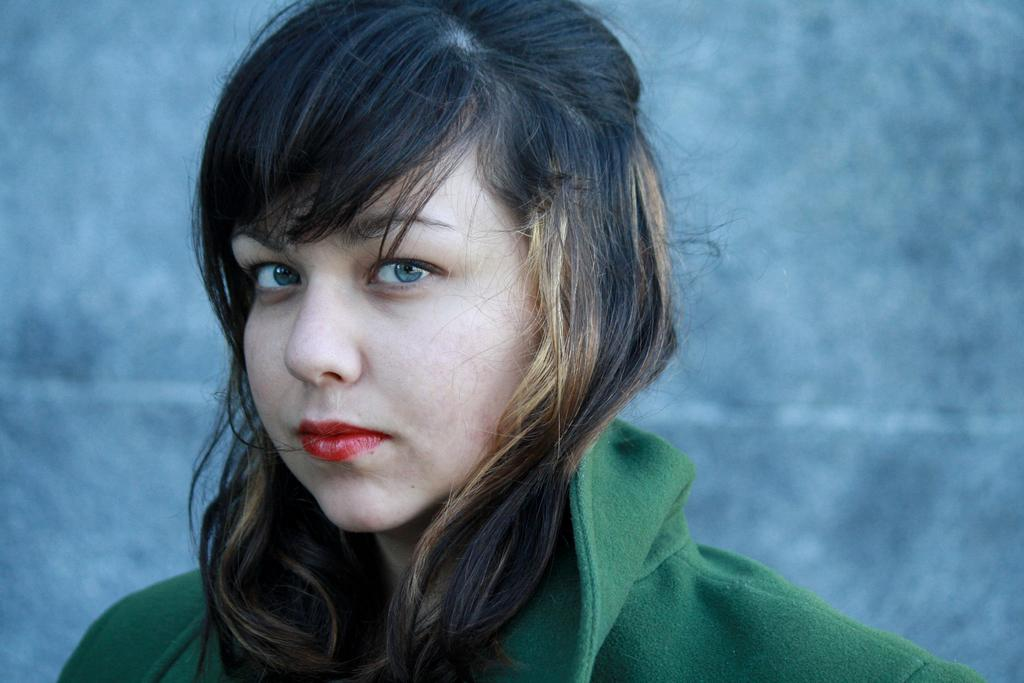What is the main subject of the image? The main subject of the image is a woman standing in the middle of the image. What is the woman doing in the image? The woman is watching. What is visible behind the woman? There is a wall behind the woman. What type of popcorn is the woman eating in the image? There is no popcorn present in the image, and therefore the woman cannot be eating any. What type of plate is the woman holding in the image? There is no plate present in the image, and therefore the woman cannot be holding any. 